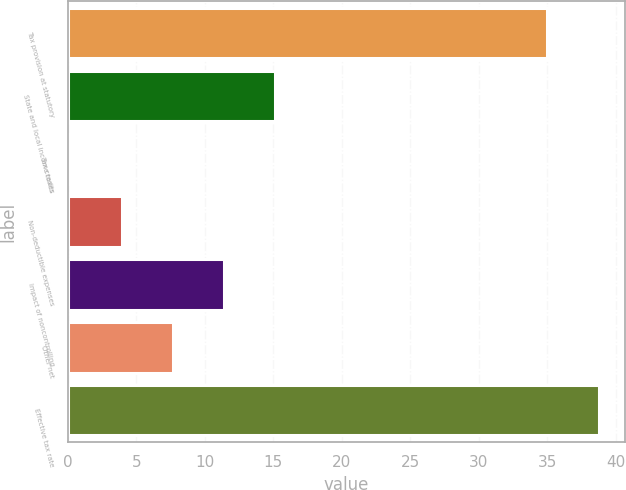Convert chart to OTSL. <chart><loc_0><loc_0><loc_500><loc_500><bar_chart><fcel>Tax provision at statutory<fcel>State and local income taxes<fcel>Tax credits<fcel>Non-deductible expenses<fcel>Impact of noncontrolling<fcel>Other net<fcel>Effective tax rate<nl><fcel>35<fcel>15.16<fcel>0.2<fcel>3.94<fcel>11.42<fcel>7.68<fcel>38.74<nl></chart> 